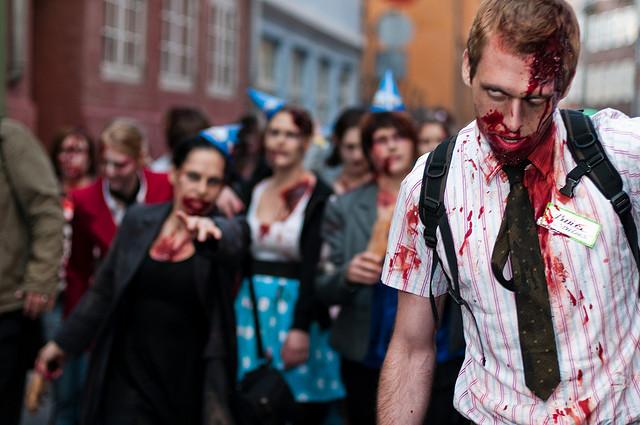Are these people zombies?
Be succinct. Yes. Is this photo in black and white?
Quick response, please. No. Is he hurt?
Short answer required. No. Is that a person wearing a mask?
Short answer required. No. Is the man planning to buy fruit?
Keep it brief. No. Do you think they're celebrating something?
Short answer required. No. Is the man injured?
Be succinct. No. What occasion is this?
Keep it brief. Halloween. Is this a party?
Keep it brief. No. How many women are shown?
Answer briefly. 6. How many green ties are there?
Concise answer only. 1. Are these authentic clothing from the past?
Keep it brief. No. 